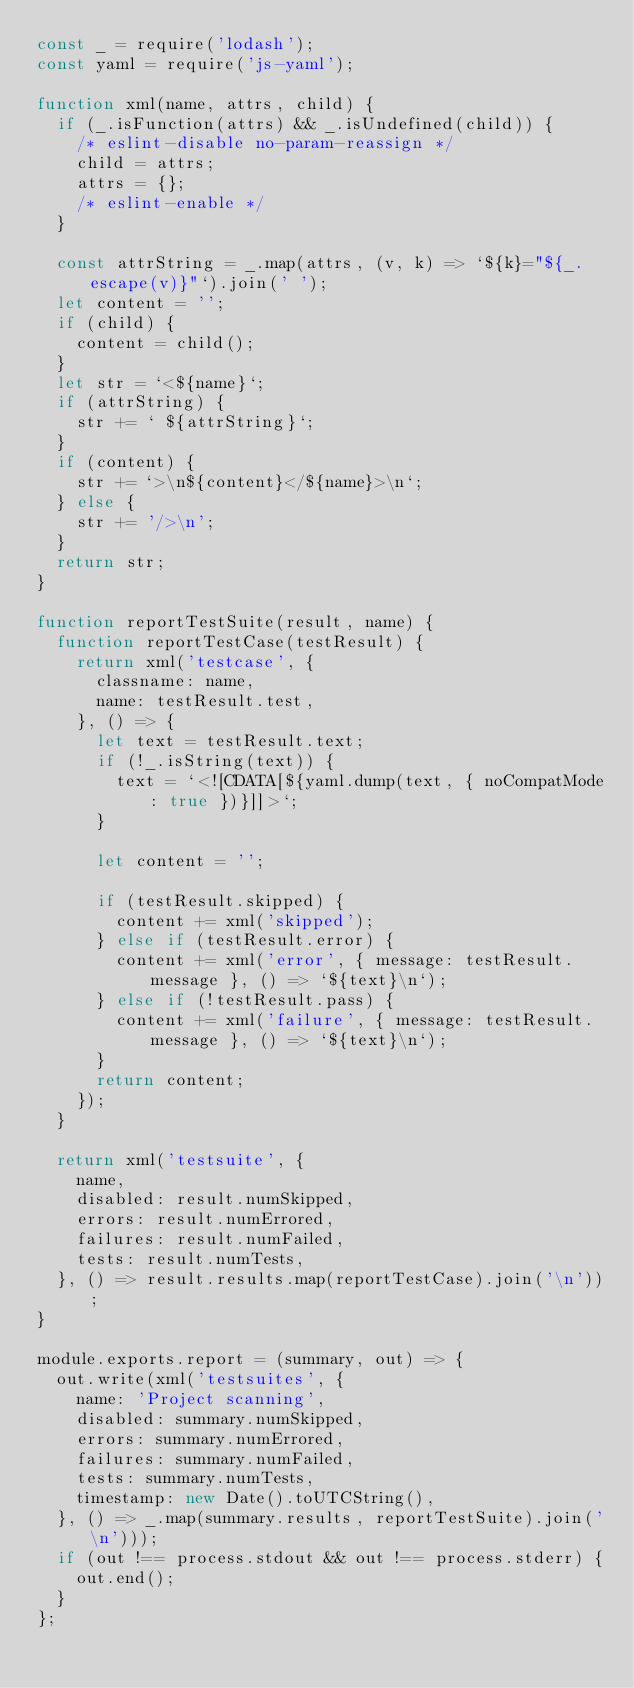<code> <loc_0><loc_0><loc_500><loc_500><_JavaScript_>const _ = require('lodash');
const yaml = require('js-yaml');

function xml(name, attrs, child) {
  if (_.isFunction(attrs) && _.isUndefined(child)) {
    /* eslint-disable no-param-reassign */
    child = attrs;
    attrs = {};
    /* eslint-enable */
  }

  const attrString = _.map(attrs, (v, k) => `${k}="${_.escape(v)}"`).join(' ');
  let content = '';
  if (child) {
    content = child();
  }
  let str = `<${name}`;
  if (attrString) {
    str += ` ${attrString}`;
  }
  if (content) {
    str += `>\n${content}</${name}>\n`;
  } else {
    str += '/>\n';
  }
  return str;
}

function reportTestSuite(result, name) {
  function reportTestCase(testResult) {
    return xml('testcase', {
      classname: name,
      name: testResult.test,
    }, () => {
      let text = testResult.text;
      if (!_.isString(text)) {
        text = `<![CDATA[${yaml.dump(text, { noCompatMode: true })}]]>`;
      }

      let content = '';

      if (testResult.skipped) {
        content += xml('skipped');
      } else if (testResult.error) {
        content += xml('error', { message: testResult.message }, () => `${text}\n`);
      } else if (!testResult.pass) {
        content += xml('failure', { message: testResult.message }, () => `${text}\n`);
      }
      return content;
    });
  }

  return xml('testsuite', {
    name,
    disabled: result.numSkipped,
    errors: result.numErrored,
    failures: result.numFailed,
    tests: result.numTests,
  }, () => result.results.map(reportTestCase).join('\n'));
}

module.exports.report = (summary, out) => {
  out.write(xml('testsuites', {
    name: 'Project scanning',
    disabled: summary.numSkipped,
    errors: summary.numErrored,
    failures: summary.numFailed,
    tests: summary.numTests,
    timestamp: new Date().toUTCString(),
  }, () => _.map(summary.results, reportTestSuite).join('\n')));
  if (out !== process.stdout && out !== process.stderr) {
    out.end();
  }
};
</code> 